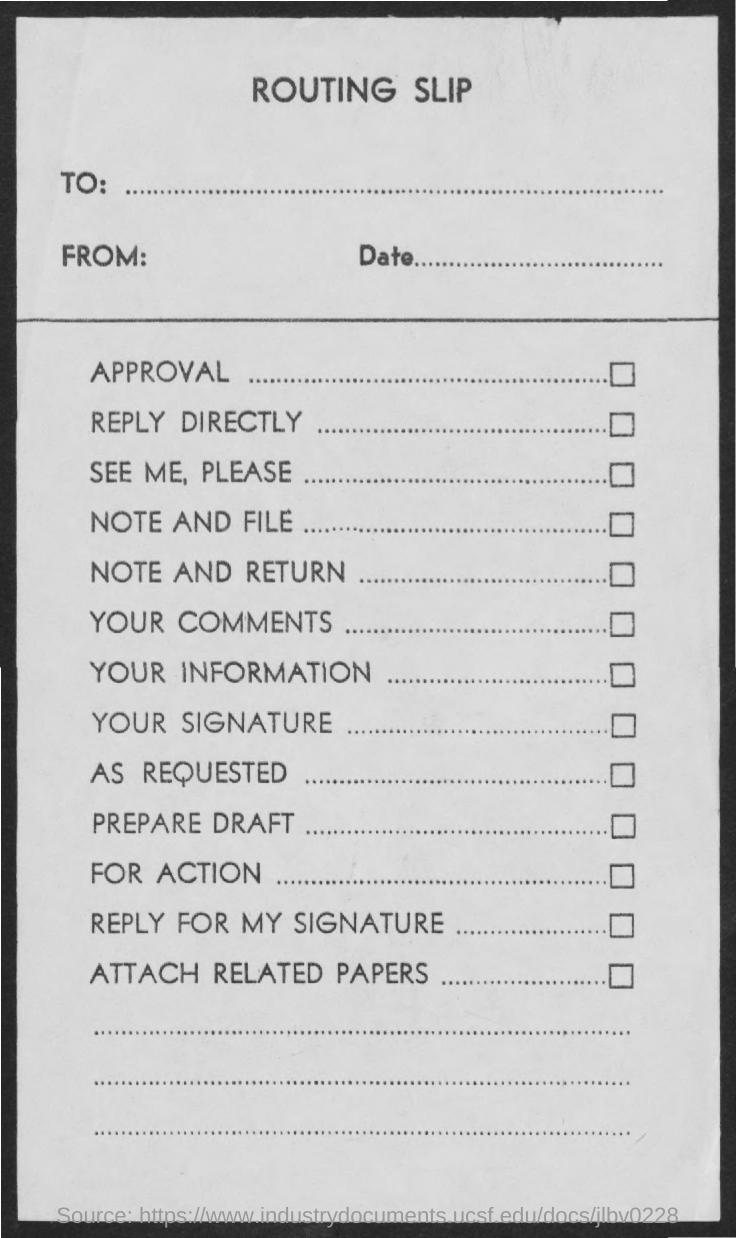What is the title of the document?
Your response must be concise. Routing Slip. 